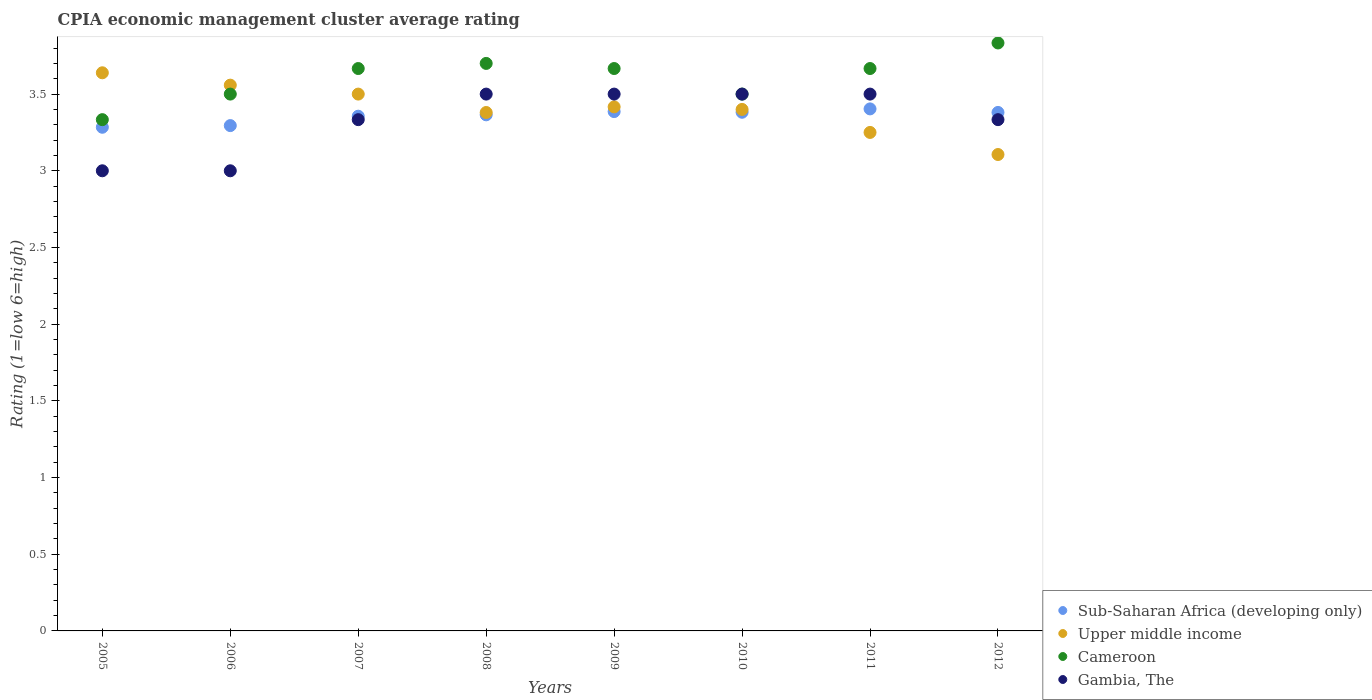What is the CPIA rating in Cameroon in 2008?
Your answer should be compact. 3.7. Across all years, what is the minimum CPIA rating in Upper middle income?
Keep it short and to the point. 3.11. In which year was the CPIA rating in Upper middle income maximum?
Keep it short and to the point. 2005. What is the total CPIA rating in Gambia, The in the graph?
Provide a short and direct response. 26.67. What is the difference between the CPIA rating in Sub-Saharan Africa (developing only) in 2006 and that in 2010?
Provide a short and direct response. -0.09. What is the average CPIA rating in Gambia, The per year?
Provide a short and direct response. 3.33. In the year 2009, what is the difference between the CPIA rating in Sub-Saharan Africa (developing only) and CPIA rating in Cameroon?
Give a very brief answer. -0.28. In how many years, is the CPIA rating in Sub-Saharan Africa (developing only) greater than 1.1?
Provide a short and direct response. 8. What is the difference between the highest and the second highest CPIA rating in Sub-Saharan Africa (developing only)?
Your response must be concise. 0.02. What is the difference between the highest and the lowest CPIA rating in Sub-Saharan Africa (developing only)?
Ensure brevity in your answer.  0.12. In how many years, is the CPIA rating in Sub-Saharan Africa (developing only) greater than the average CPIA rating in Sub-Saharan Africa (developing only) taken over all years?
Offer a terse response. 5. Is the sum of the CPIA rating in Cameroon in 2005 and 2006 greater than the maximum CPIA rating in Sub-Saharan Africa (developing only) across all years?
Offer a very short reply. Yes. Is it the case that in every year, the sum of the CPIA rating in Upper middle income and CPIA rating in Sub-Saharan Africa (developing only)  is greater than the CPIA rating in Gambia, The?
Ensure brevity in your answer.  Yes. Does the CPIA rating in Gambia, The monotonically increase over the years?
Offer a very short reply. No. Is the CPIA rating in Upper middle income strictly greater than the CPIA rating in Sub-Saharan Africa (developing only) over the years?
Offer a terse response. No. What is the difference between two consecutive major ticks on the Y-axis?
Provide a succinct answer. 0.5. Are the values on the major ticks of Y-axis written in scientific E-notation?
Keep it short and to the point. No. Does the graph contain any zero values?
Keep it short and to the point. No. How many legend labels are there?
Provide a short and direct response. 4. How are the legend labels stacked?
Provide a succinct answer. Vertical. What is the title of the graph?
Provide a succinct answer. CPIA economic management cluster average rating. What is the Rating (1=low 6=high) in Sub-Saharan Africa (developing only) in 2005?
Give a very brief answer. 3.28. What is the Rating (1=low 6=high) of Upper middle income in 2005?
Ensure brevity in your answer.  3.64. What is the Rating (1=low 6=high) in Cameroon in 2005?
Make the answer very short. 3.33. What is the Rating (1=low 6=high) of Sub-Saharan Africa (developing only) in 2006?
Provide a short and direct response. 3.29. What is the Rating (1=low 6=high) of Upper middle income in 2006?
Make the answer very short. 3.56. What is the Rating (1=low 6=high) in Sub-Saharan Africa (developing only) in 2007?
Offer a very short reply. 3.36. What is the Rating (1=low 6=high) in Cameroon in 2007?
Offer a terse response. 3.67. What is the Rating (1=low 6=high) in Gambia, The in 2007?
Offer a very short reply. 3.33. What is the Rating (1=low 6=high) in Sub-Saharan Africa (developing only) in 2008?
Ensure brevity in your answer.  3.36. What is the Rating (1=low 6=high) in Upper middle income in 2008?
Offer a terse response. 3.38. What is the Rating (1=low 6=high) in Cameroon in 2008?
Keep it short and to the point. 3.7. What is the Rating (1=low 6=high) in Gambia, The in 2008?
Provide a succinct answer. 3.5. What is the Rating (1=low 6=high) in Sub-Saharan Africa (developing only) in 2009?
Keep it short and to the point. 3.39. What is the Rating (1=low 6=high) of Upper middle income in 2009?
Keep it short and to the point. 3.42. What is the Rating (1=low 6=high) in Cameroon in 2009?
Your answer should be very brief. 3.67. What is the Rating (1=low 6=high) of Sub-Saharan Africa (developing only) in 2010?
Offer a terse response. 3.38. What is the Rating (1=low 6=high) of Upper middle income in 2010?
Offer a very short reply. 3.4. What is the Rating (1=low 6=high) of Gambia, The in 2010?
Offer a very short reply. 3.5. What is the Rating (1=low 6=high) in Sub-Saharan Africa (developing only) in 2011?
Provide a succinct answer. 3.4. What is the Rating (1=low 6=high) in Upper middle income in 2011?
Your response must be concise. 3.25. What is the Rating (1=low 6=high) of Cameroon in 2011?
Ensure brevity in your answer.  3.67. What is the Rating (1=low 6=high) of Gambia, The in 2011?
Give a very brief answer. 3.5. What is the Rating (1=low 6=high) in Sub-Saharan Africa (developing only) in 2012?
Offer a terse response. 3.38. What is the Rating (1=low 6=high) in Upper middle income in 2012?
Offer a very short reply. 3.11. What is the Rating (1=low 6=high) of Cameroon in 2012?
Provide a short and direct response. 3.83. What is the Rating (1=low 6=high) of Gambia, The in 2012?
Give a very brief answer. 3.33. Across all years, what is the maximum Rating (1=low 6=high) in Sub-Saharan Africa (developing only)?
Keep it short and to the point. 3.4. Across all years, what is the maximum Rating (1=low 6=high) of Upper middle income?
Your response must be concise. 3.64. Across all years, what is the maximum Rating (1=low 6=high) in Cameroon?
Offer a terse response. 3.83. Across all years, what is the minimum Rating (1=low 6=high) of Sub-Saharan Africa (developing only)?
Offer a very short reply. 3.28. Across all years, what is the minimum Rating (1=low 6=high) in Upper middle income?
Ensure brevity in your answer.  3.11. Across all years, what is the minimum Rating (1=low 6=high) in Cameroon?
Provide a short and direct response. 3.33. Across all years, what is the minimum Rating (1=low 6=high) of Gambia, The?
Offer a very short reply. 3. What is the total Rating (1=low 6=high) of Sub-Saharan Africa (developing only) in the graph?
Your answer should be very brief. 26.85. What is the total Rating (1=low 6=high) in Upper middle income in the graph?
Your response must be concise. 27.25. What is the total Rating (1=low 6=high) in Cameroon in the graph?
Your response must be concise. 28.87. What is the total Rating (1=low 6=high) in Gambia, The in the graph?
Offer a very short reply. 26.67. What is the difference between the Rating (1=low 6=high) in Sub-Saharan Africa (developing only) in 2005 and that in 2006?
Ensure brevity in your answer.  -0.01. What is the difference between the Rating (1=low 6=high) in Upper middle income in 2005 and that in 2006?
Ensure brevity in your answer.  0.08. What is the difference between the Rating (1=low 6=high) in Cameroon in 2005 and that in 2006?
Provide a short and direct response. -0.17. What is the difference between the Rating (1=low 6=high) in Gambia, The in 2005 and that in 2006?
Make the answer very short. 0. What is the difference between the Rating (1=low 6=high) of Sub-Saharan Africa (developing only) in 2005 and that in 2007?
Offer a terse response. -0.07. What is the difference between the Rating (1=low 6=high) of Upper middle income in 2005 and that in 2007?
Give a very brief answer. 0.14. What is the difference between the Rating (1=low 6=high) in Gambia, The in 2005 and that in 2007?
Ensure brevity in your answer.  -0.33. What is the difference between the Rating (1=low 6=high) of Sub-Saharan Africa (developing only) in 2005 and that in 2008?
Your answer should be very brief. -0.08. What is the difference between the Rating (1=low 6=high) of Upper middle income in 2005 and that in 2008?
Make the answer very short. 0.26. What is the difference between the Rating (1=low 6=high) of Cameroon in 2005 and that in 2008?
Your answer should be very brief. -0.37. What is the difference between the Rating (1=low 6=high) in Gambia, The in 2005 and that in 2008?
Offer a terse response. -0.5. What is the difference between the Rating (1=low 6=high) in Sub-Saharan Africa (developing only) in 2005 and that in 2009?
Keep it short and to the point. -0.1. What is the difference between the Rating (1=low 6=high) of Upper middle income in 2005 and that in 2009?
Keep it short and to the point. 0.22. What is the difference between the Rating (1=low 6=high) of Sub-Saharan Africa (developing only) in 2005 and that in 2010?
Your response must be concise. -0.1. What is the difference between the Rating (1=low 6=high) of Upper middle income in 2005 and that in 2010?
Provide a short and direct response. 0.24. What is the difference between the Rating (1=low 6=high) in Sub-Saharan Africa (developing only) in 2005 and that in 2011?
Offer a terse response. -0.12. What is the difference between the Rating (1=low 6=high) in Upper middle income in 2005 and that in 2011?
Your answer should be compact. 0.39. What is the difference between the Rating (1=low 6=high) in Cameroon in 2005 and that in 2011?
Provide a succinct answer. -0.33. What is the difference between the Rating (1=low 6=high) of Gambia, The in 2005 and that in 2011?
Make the answer very short. -0.5. What is the difference between the Rating (1=low 6=high) of Sub-Saharan Africa (developing only) in 2005 and that in 2012?
Provide a short and direct response. -0.1. What is the difference between the Rating (1=low 6=high) in Upper middle income in 2005 and that in 2012?
Provide a short and direct response. 0.53. What is the difference between the Rating (1=low 6=high) in Cameroon in 2005 and that in 2012?
Your response must be concise. -0.5. What is the difference between the Rating (1=low 6=high) in Sub-Saharan Africa (developing only) in 2006 and that in 2007?
Offer a very short reply. -0.06. What is the difference between the Rating (1=low 6=high) in Upper middle income in 2006 and that in 2007?
Offer a terse response. 0.06. What is the difference between the Rating (1=low 6=high) of Cameroon in 2006 and that in 2007?
Provide a short and direct response. -0.17. What is the difference between the Rating (1=low 6=high) in Gambia, The in 2006 and that in 2007?
Your answer should be very brief. -0.33. What is the difference between the Rating (1=low 6=high) in Sub-Saharan Africa (developing only) in 2006 and that in 2008?
Make the answer very short. -0.07. What is the difference between the Rating (1=low 6=high) in Upper middle income in 2006 and that in 2008?
Make the answer very short. 0.18. What is the difference between the Rating (1=low 6=high) in Gambia, The in 2006 and that in 2008?
Offer a very short reply. -0.5. What is the difference between the Rating (1=low 6=high) in Sub-Saharan Africa (developing only) in 2006 and that in 2009?
Provide a succinct answer. -0.09. What is the difference between the Rating (1=low 6=high) in Upper middle income in 2006 and that in 2009?
Ensure brevity in your answer.  0.14. What is the difference between the Rating (1=low 6=high) of Gambia, The in 2006 and that in 2009?
Your answer should be compact. -0.5. What is the difference between the Rating (1=low 6=high) in Sub-Saharan Africa (developing only) in 2006 and that in 2010?
Make the answer very short. -0.09. What is the difference between the Rating (1=low 6=high) of Upper middle income in 2006 and that in 2010?
Keep it short and to the point. 0.16. What is the difference between the Rating (1=low 6=high) of Cameroon in 2006 and that in 2010?
Your response must be concise. 0. What is the difference between the Rating (1=low 6=high) in Gambia, The in 2006 and that in 2010?
Keep it short and to the point. -0.5. What is the difference between the Rating (1=low 6=high) of Sub-Saharan Africa (developing only) in 2006 and that in 2011?
Offer a terse response. -0.11. What is the difference between the Rating (1=low 6=high) in Upper middle income in 2006 and that in 2011?
Make the answer very short. 0.31. What is the difference between the Rating (1=low 6=high) in Gambia, The in 2006 and that in 2011?
Give a very brief answer. -0.5. What is the difference between the Rating (1=low 6=high) of Sub-Saharan Africa (developing only) in 2006 and that in 2012?
Ensure brevity in your answer.  -0.09. What is the difference between the Rating (1=low 6=high) of Upper middle income in 2006 and that in 2012?
Keep it short and to the point. 0.45. What is the difference between the Rating (1=low 6=high) in Gambia, The in 2006 and that in 2012?
Make the answer very short. -0.33. What is the difference between the Rating (1=low 6=high) of Sub-Saharan Africa (developing only) in 2007 and that in 2008?
Make the answer very short. -0.01. What is the difference between the Rating (1=low 6=high) in Upper middle income in 2007 and that in 2008?
Offer a terse response. 0.12. What is the difference between the Rating (1=low 6=high) of Cameroon in 2007 and that in 2008?
Ensure brevity in your answer.  -0.03. What is the difference between the Rating (1=low 6=high) of Sub-Saharan Africa (developing only) in 2007 and that in 2009?
Your answer should be compact. -0.03. What is the difference between the Rating (1=low 6=high) of Upper middle income in 2007 and that in 2009?
Offer a very short reply. 0.08. What is the difference between the Rating (1=low 6=high) of Cameroon in 2007 and that in 2009?
Keep it short and to the point. 0. What is the difference between the Rating (1=low 6=high) of Sub-Saharan Africa (developing only) in 2007 and that in 2010?
Your answer should be very brief. -0.03. What is the difference between the Rating (1=low 6=high) in Sub-Saharan Africa (developing only) in 2007 and that in 2011?
Ensure brevity in your answer.  -0.05. What is the difference between the Rating (1=low 6=high) in Upper middle income in 2007 and that in 2011?
Offer a terse response. 0.25. What is the difference between the Rating (1=low 6=high) of Cameroon in 2007 and that in 2011?
Offer a terse response. 0. What is the difference between the Rating (1=low 6=high) of Gambia, The in 2007 and that in 2011?
Make the answer very short. -0.17. What is the difference between the Rating (1=low 6=high) of Sub-Saharan Africa (developing only) in 2007 and that in 2012?
Keep it short and to the point. -0.02. What is the difference between the Rating (1=low 6=high) in Upper middle income in 2007 and that in 2012?
Your response must be concise. 0.39. What is the difference between the Rating (1=low 6=high) in Cameroon in 2007 and that in 2012?
Offer a very short reply. -0.17. What is the difference between the Rating (1=low 6=high) in Sub-Saharan Africa (developing only) in 2008 and that in 2009?
Offer a very short reply. -0.02. What is the difference between the Rating (1=low 6=high) of Upper middle income in 2008 and that in 2009?
Provide a short and direct response. -0.04. What is the difference between the Rating (1=low 6=high) in Cameroon in 2008 and that in 2009?
Your answer should be very brief. 0.03. What is the difference between the Rating (1=low 6=high) of Gambia, The in 2008 and that in 2009?
Provide a short and direct response. 0. What is the difference between the Rating (1=low 6=high) in Sub-Saharan Africa (developing only) in 2008 and that in 2010?
Provide a short and direct response. -0.02. What is the difference between the Rating (1=low 6=high) of Upper middle income in 2008 and that in 2010?
Keep it short and to the point. -0.02. What is the difference between the Rating (1=low 6=high) of Gambia, The in 2008 and that in 2010?
Your answer should be compact. 0. What is the difference between the Rating (1=low 6=high) of Sub-Saharan Africa (developing only) in 2008 and that in 2011?
Offer a very short reply. -0.04. What is the difference between the Rating (1=low 6=high) of Upper middle income in 2008 and that in 2011?
Give a very brief answer. 0.13. What is the difference between the Rating (1=low 6=high) in Gambia, The in 2008 and that in 2011?
Ensure brevity in your answer.  0. What is the difference between the Rating (1=low 6=high) of Sub-Saharan Africa (developing only) in 2008 and that in 2012?
Keep it short and to the point. -0.02. What is the difference between the Rating (1=low 6=high) in Upper middle income in 2008 and that in 2012?
Give a very brief answer. 0.27. What is the difference between the Rating (1=low 6=high) in Cameroon in 2008 and that in 2012?
Provide a succinct answer. -0.13. What is the difference between the Rating (1=low 6=high) of Sub-Saharan Africa (developing only) in 2009 and that in 2010?
Give a very brief answer. 0. What is the difference between the Rating (1=low 6=high) of Upper middle income in 2009 and that in 2010?
Your answer should be very brief. 0.02. What is the difference between the Rating (1=low 6=high) in Cameroon in 2009 and that in 2010?
Provide a succinct answer. 0.17. What is the difference between the Rating (1=low 6=high) of Gambia, The in 2009 and that in 2010?
Offer a terse response. 0. What is the difference between the Rating (1=low 6=high) of Sub-Saharan Africa (developing only) in 2009 and that in 2011?
Offer a very short reply. -0.02. What is the difference between the Rating (1=low 6=high) of Upper middle income in 2009 and that in 2011?
Make the answer very short. 0.17. What is the difference between the Rating (1=low 6=high) of Sub-Saharan Africa (developing only) in 2009 and that in 2012?
Your answer should be very brief. 0.01. What is the difference between the Rating (1=low 6=high) of Upper middle income in 2009 and that in 2012?
Your answer should be compact. 0.31. What is the difference between the Rating (1=low 6=high) in Cameroon in 2009 and that in 2012?
Offer a terse response. -0.17. What is the difference between the Rating (1=low 6=high) in Sub-Saharan Africa (developing only) in 2010 and that in 2011?
Your answer should be very brief. -0.02. What is the difference between the Rating (1=low 6=high) in Sub-Saharan Africa (developing only) in 2010 and that in 2012?
Your response must be concise. 0. What is the difference between the Rating (1=low 6=high) in Upper middle income in 2010 and that in 2012?
Offer a terse response. 0.29. What is the difference between the Rating (1=low 6=high) in Gambia, The in 2010 and that in 2012?
Provide a succinct answer. 0.17. What is the difference between the Rating (1=low 6=high) of Sub-Saharan Africa (developing only) in 2011 and that in 2012?
Offer a very short reply. 0.02. What is the difference between the Rating (1=low 6=high) in Upper middle income in 2011 and that in 2012?
Offer a very short reply. 0.14. What is the difference between the Rating (1=low 6=high) in Cameroon in 2011 and that in 2012?
Offer a very short reply. -0.17. What is the difference between the Rating (1=low 6=high) of Gambia, The in 2011 and that in 2012?
Your answer should be compact. 0.17. What is the difference between the Rating (1=low 6=high) in Sub-Saharan Africa (developing only) in 2005 and the Rating (1=low 6=high) in Upper middle income in 2006?
Provide a succinct answer. -0.27. What is the difference between the Rating (1=low 6=high) in Sub-Saharan Africa (developing only) in 2005 and the Rating (1=low 6=high) in Cameroon in 2006?
Keep it short and to the point. -0.22. What is the difference between the Rating (1=low 6=high) in Sub-Saharan Africa (developing only) in 2005 and the Rating (1=low 6=high) in Gambia, The in 2006?
Offer a very short reply. 0.28. What is the difference between the Rating (1=low 6=high) of Upper middle income in 2005 and the Rating (1=low 6=high) of Cameroon in 2006?
Your answer should be very brief. 0.14. What is the difference between the Rating (1=low 6=high) of Upper middle income in 2005 and the Rating (1=low 6=high) of Gambia, The in 2006?
Make the answer very short. 0.64. What is the difference between the Rating (1=low 6=high) of Sub-Saharan Africa (developing only) in 2005 and the Rating (1=low 6=high) of Upper middle income in 2007?
Ensure brevity in your answer.  -0.22. What is the difference between the Rating (1=low 6=high) of Sub-Saharan Africa (developing only) in 2005 and the Rating (1=low 6=high) of Cameroon in 2007?
Ensure brevity in your answer.  -0.38. What is the difference between the Rating (1=low 6=high) of Sub-Saharan Africa (developing only) in 2005 and the Rating (1=low 6=high) of Gambia, The in 2007?
Offer a very short reply. -0.05. What is the difference between the Rating (1=low 6=high) of Upper middle income in 2005 and the Rating (1=low 6=high) of Cameroon in 2007?
Your answer should be very brief. -0.03. What is the difference between the Rating (1=low 6=high) of Upper middle income in 2005 and the Rating (1=low 6=high) of Gambia, The in 2007?
Offer a terse response. 0.31. What is the difference between the Rating (1=low 6=high) in Sub-Saharan Africa (developing only) in 2005 and the Rating (1=low 6=high) in Upper middle income in 2008?
Your answer should be compact. -0.1. What is the difference between the Rating (1=low 6=high) in Sub-Saharan Africa (developing only) in 2005 and the Rating (1=low 6=high) in Cameroon in 2008?
Keep it short and to the point. -0.42. What is the difference between the Rating (1=low 6=high) in Sub-Saharan Africa (developing only) in 2005 and the Rating (1=low 6=high) in Gambia, The in 2008?
Your answer should be very brief. -0.22. What is the difference between the Rating (1=low 6=high) in Upper middle income in 2005 and the Rating (1=low 6=high) in Cameroon in 2008?
Provide a succinct answer. -0.06. What is the difference between the Rating (1=low 6=high) of Upper middle income in 2005 and the Rating (1=low 6=high) of Gambia, The in 2008?
Your answer should be compact. 0.14. What is the difference between the Rating (1=low 6=high) in Sub-Saharan Africa (developing only) in 2005 and the Rating (1=low 6=high) in Upper middle income in 2009?
Offer a very short reply. -0.13. What is the difference between the Rating (1=low 6=high) in Sub-Saharan Africa (developing only) in 2005 and the Rating (1=low 6=high) in Cameroon in 2009?
Provide a succinct answer. -0.38. What is the difference between the Rating (1=low 6=high) of Sub-Saharan Africa (developing only) in 2005 and the Rating (1=low 6=high) of Gambia, The in 2009?
Offer a terse response. -0.22. What is the difference between the Rating (1=low 6=high) in Upper middle income in 2005 and the Rating (1=low 6=high) in Cameroon in 2009?
Your response must be concise. -0.03. What is the difference between the Rating (1=low 6=high) of Upper middle income in 2005 and the Rating (1=low 6=high) of Gambia, The in 2009?
Ensure brevity in your answer.  0.14. What is the difference between the Rating (1=low 6=high) of Sub-Saharan Africa (developing only) in 2005 and the Rating (1=low 6=high) of Upper middle income in 2010?
Provide a succinct answer. -0.12. What is the difference between the Rating (1=low 6=high) of Sub-Saharan Africa (developing only) in 2005 and the Rating (1=low 6=high) of Cameroon in 2010?
Offer a terse response. -0.22. What is the difference between the Rating (1=low 6=high) of Sub-Saharan Africa (developing only) in 2005 and the Rating (1=low 6=high) of Gambia, The in 2010?
Provide a succinct answer. -0.22. What is the difference between the Rating (1=low 6=high) in Upper middle income in 2005 and the Rating (1=low 6=high) in Cameroon in 2010?
Your response must be concise. 0.14. What is the difference between the Rating (1=low 6=high) of Upper middle income in 2005 and the Rating (1=low 6=high) of Gambia, The in 2010?
Ensure brevity in your answer.  0.14. What is the difference between the Rating (1=low 6=high) in Cameroon in 2005 and the Rating (1=low 6=high) in Gambia, The in 2010?
Offer a terse response. -0.17. What is the difference between the Rating (1=low 6=high) of Sub-Saharan Africa (developing only) in 2005 and the Rating (1=low 6=high) of Upper middle income in 2011?
Ensure brevity in your answer.  0.03. What is the difference between the Rating (1=low 6=high) in Sub-Saharan Africa (developing only) in 2005 and the Rating (1=low 6=high) in Cameroon in 2011?
Provide a short and direct response. -0.38. What is the difference between the Rating (1=low 6=high) of Sub-Saharan Africa (developing only) in 2005 and the Rating (1=low 6=high) of Gambia, The in 2011?
Keep it short and to the point. -0.22. What is the difference between the Rating (1=low 6=high) in Upper middle income in 2005 and the Rating (1=low 6=high) in Cameroon in 2011?
Offer a terse response. -0.03. What is the difference between the Rating (1=low 6=high) in Upper middle income in 2005 and the Rating (1=low 6=high) in Gambia, The in 2011?
Give a very brief answer. 0.14. What is the difference between the Rating (1=low 6=high) in Sub-Saharan Africa (developing only) in 2005 and the Rating (1=low 6=high) in Upper middle income in 2012?
Provide a succinct answer. 0.18. What is the difference between the Rating (1=low 6=high) of Sub-Saharan Africa (developing only) in 2005 and the Rating (1=low 6=high) of Cameroon in 2012?
Your answer should be very brief. -0.55. What is the difference between the Rating (1=low 6=high) in Sub-Saharan Africa (developing only) in 2005 and the Rating (1=low 6=high) in Gambia, The in 2012?
Give a very brief answer. -0.05. What is the difference between the Rating (1=low 6=high) of Upper middle income in 2005 and the Rating (1=low 6=high) of Cameroon in 2012?
Make the answer very short. -0.19. What is the difference between the Rating (1=low 6=high) of Upper middle income in 2005 and the Rating (1=low 6=high) of Gambia, The in 2012?
Provide a succinct answer. 0.31. What is the difference between the Rating (1=low 6=high) in Cameroon in 2005 and the Rating (1=low 6=high) in Gambia, The in 2012?
Offer a very short reply. 0. What is the difference between the Rating (1=low 6=high) of Sub-Saharan Africa (developing only) in 2006 and the Rating (1=low 6=high) of Upper middle income in 2007?
Offer a very short reply. -0.21. What is the difference between the Rating (1=low 6=high) in Sub-Saharan Africa (developing only) in 2006 and the Rating (1=low 6=high) in Cameroon in 2007?
Keep it short and to the point. -0.37. What is the difference between the Rating (1=low 6=high) of Sub-Saharan Africa (developing only) in 2006 and the Rating (1=low 6=high) of Gambia, The in 2007?
Make the answer very short. -0.04. What is the difference between the Rating (1=low 6=high) of Upper middle income in 2006 and the Rating (1=low 6=high) of Cameroon in 2007?
Your answer should be very brief. -0.11. What is the difference between the Rating (1=low 6=high) in Upper middle income in 2006 and the Rating (1=low 6=high) in Gambia, The in 2007?
Offer a very short reply. 0.23. What is the difference between the Rating (1=low 6=high) of Cameroon in 2006 and the Rating (1=low 6=high) of Gambia, The in 2007?
Ensure brevity in your answer.  0.17. What is the difference between the Rating (1=low 6=high) of Sub-Saharan Africa (developing only) in 2006 and the Rating (1=low 6=high) of Upper middle income in 2008?
Your answer should be compact. -0.09. What is the difference between the Rating (1=low 6=high) in Sub-Saharan Africa (developing only) in 2006 and the Rating (1=low 6=high) in Cameroon in 2008?
Offer a very short reply. -0.41. What is the difference between the Rating (1=low 6=high) in Sub-Saharan Africa (developing only) in 2006 and the Rating (1=low 6=high) in Gambia, The in 2008?
Keep it short and to the point. -0.21. What is the difference between the Rating (1=low 6=high) of Upper middle income in 2006 and the Rating (1=low 6=high) of Cameroon in 2008?
Give a very brief answer. -0.14. What is the difference between the Rating (1=low 6=high) in Upper middle income in 2006 and the Rating (1=low 6=high) in Gambia, The in 2008?
Make the answer very short. 0.06. What is the difference between the Rating (1=low 6=high) in Cameroon in 2006 and the Rating (1=low 6=high) in Gambia, The in 2008?
Your response must be concise. 0. What is the difference between the Rating (1=low 6=high) in Sub-Saharan Africa (developing only) in 2006 and the Rating (1=low 6=high) in Upper middle income in 2009?
Give a very brief answer. -0.12. What is the difference between the Rating (1=low 6=high) of Sub-Saharan Africa (developing only) in 2006 and the Rating (1=low 6=high) of Cameroon in 2009?
Provide a short and direct response. -0.37. What is the difference between the Rating (1=low 6=high) of Sub-Saharan Africa (developing only) in 2006 and the Rating (1=low 6=high) of Gambia, The in 2009?
Your response must be concise. -0.21. What is the difference between the Rating (1=low 6=high) of Upper middle income in 2006 and the Rating (1=low 6=high) of Cameroon in 2009?
Your response must be concise. -0.11. What is the difference between the Rating (1=low 6=high) in Upper middle income in 2006 and the Rating (1=low 6=high) in Gambia, The in 2009?
Provide a short and direct response. 0.06. What is the difference between the Rating (1=low 6=high) in Sub-Saharan Africa (developing only) in 2006 and the Rating (1=low 6=high) in Upper middle income in 2010?
Offer a very short reply. -0.11. What is the difference between the Rating (1=low 6=high) of Sub-Saharan Africa (developing only) in 2006 and the Rating (1=low 6=high) of Cameroon in 2010?
Offer a very short reply. -0.21. What is the difference between the Rating (1=low 6=high) in Sub-Saharan Africa (developing only) in 2006 and the Rating (1=low 6=high) in Gambia, The in 2010?
Give a very brief answer. -0.21. What is the difference between the Rating (1=low 6=high) in Upper middle income in 2006 and the Rating (1=low 6=high) in Cameroon in 2010?
Your response must be concise. 0.06. What is the difference between the Rating (1=low 6=high) of Upper middle income in 2006 and the Rating (1=low 6=high) of Gambia, The in 2010?
Offer a very short reply. 0.06. What is the difference between the Rating (1=low 6=high) of Sub-Saharan Africa (developing only) in 2006 and the Rating (1=low 6=high) of Upper middle income in 2011?
Keep it short and to the point. 0.04. What is the difference between the Rating (1=low 6=high) of Sub-Saharan Africa (developing only) in 2006 and the Rating (1=low 6=high) of Cameroon in 2011?
Ensure brevity in your answer.  -0.37. What is the difference between the Rating (1=low 6=high) in Sub-Saharan Africa (developing only) in 2006 and the Rating (1=low 6=high) in Gambia, The in 2011?
Keep it short and to the point. -0.21. What is the difference between the Rating (1=low 6=high) in Upper middle income in 2006 and the Rating (1=low 6=high) in Cameroon in 2011?
Give a very brief answer. -0.11. What is the difference between the Rating (1=low 6=high) in Upper middle income in 2006 and the Rating (1=low 6=high) in Gambia, The in 2011?
Your answer should be very brief. 0.06. What is the difference between the Rating (1=low 6=high) of Sub-Saharan Africa (developing only) in 2006 and the Rating (1=low 6=high) of Upper middle income in 2012?
Make the answer very short. 0.19. What is the difference between the Rating (1=low 6=high) of Sub-Saharan Africa (developing only) in 2006 and the Rating (1=low 6=high) of Cameroon in 2012?
Your answer should be compact. -0.54. What is the difference between the Rating (1=low 6=high) in Sub-Saharan Africa (developing only) in 2006 and the Rating (1=low 6=high) in Gambia, The in 2012?
Provide a short and direct response. -0.04. What is the difference between the Rating (1=low 6=high) in Upper middle income in 2006 and the Rating (1=low 6=high) in Cameroon in 2012?
Your answer should be compact. -0.28. What is the difference between the Rating (1=low 6=high) in Upper middle income in 2006 and the Rating (1=low 6=high) in Gambia, The in 2012?
Give a very brief answer. 0.23. What is the difference between the Rating (1=low 6=high) in Sub-Saharan Africa (developing only) in 2007 and the Rating (1=low 6=high) in Upper middle income in 2008?
Provide a short and direct response. -0.02. What is the difference between the Rating (1=low 6=high) of Sub-Saharan Africa (developing only) in 2007 and the Rating (1=low 6=high) of Cameroon in 2008?
Provide a succinct answer. -0.34. What is the difference between the Rating (1=low 6=high) of Sub-Saharan Africa (developing only) in 2007 and the Rating (1=low 6=high) of Gambia, The in 2008?
Your answer should be compact. -0.14. What is the difference between the Rating (1=low 6=high) of Upper middle income in 2007 and the Rating (1=low 6=high) of Gambia, The in 2008?
Provide a succinct answer. 0. What is the difference between the Rating (1=low 6=high) of Cameroon in 2007 and the Rating (1=low 6=high) of Gambia, The in 2008?
Ensure brevity in your answer.  0.17. What is the difference between the Rating (1=low 6=high) of Sub-Saharan Africa (developing only) in 2007 and the Rating (1=low 6=high) of Upper middle income in 2009?
Give a very brief answer. -0.06. What is the difference between the Rating (1=low 6=high) in Sub-Saharan Africa (developing only) in 2007 and the Rating (1=low 6=high) in Cameroon in 2009?
Ensure brevity in your answer.  -0.31. What is the difference between the Rating (1=low 6=high) in Sub-Saharan Africa (developing only) in 2007 and the Rating (1=low 6=high) in Gambia, The in 2009?
Offer a terse response. -0.14. What is the difference between the Rating (1=low 6=high) in Upper middle income in 2007 and the Rating (1=low 6=high) in Cameroon in 2009?
Your answer should be very brief. -0.17. What is the difference between the Rating (1=low 6=high) of Upper middle income in 2007 and the Rating (1=low 6=high) of Gambia, The in 2009?
Ensure brevity in your answer.  0. What is the difference between the Rating (1=low 6=high) in Cameroon in 2007 and the Rating (1=low 6=high) in Gambia, The in 2009?
Your response must be concise. 0.17. What is the difference between the Rating (1=low 6=high) of Sub-Saharan Africa (developing only) in 2007 and the Rating (1=low 6=high) of Upper middle income in 2010?
Keep it short and to the point. -0.04. What is the difference between the Rating (1=low 6=high) of Sub-Saharan Africa (developing only) in 2007 and the Rating (1=low 6=high) of Cameroon in 2010?
Ensure brevity in your answer.  -0.14. What is the difference between the Rating (1=low 6=high) of Sub-Saharan Africa (developing only) in 2007 and the Rating (1=low 6=high) of Gambia, The in 2010?
Provide a short and direct response. -0.14. What is the difference between the Rating (1=low 6=high) of Sub-Saharan Africa (developing only) in 2007 and the Rating (1=low 6=high) of Upper middle income in 2011?
Your answer should be compact. 0.11. What is the difference between the Rating (1=low 6=high) of Sub-Saharan Africa (developing only) in 2007 and the Rating (1=low 6=high) of Cameroon in 2011?
Offer a very short reply. -0.31. What is the difference between the Rating (1=low 6=high) in Sub-Saharan Africa (developing only) in 2007 and the Rating (1=low 6=high) in Gambia, The in 2011?
Your response must be concise. -0.14. What is the difference between the Rating (1=low 6=high) of Upper middle income in 2007 and the Rating (1=low 6=high) of Gambia, The in 2011?
Provide a short and direct response. 0. What is the difference between the Rating (1=low 6=high) in Sub-Saharan Africa (developing only) in 2007 and the Rating (1=low 6=high) in Upper middle income in 2012?
Ensure brevity in your answer.  0.25. What is the difference between the Rating (1=low 6=high) in Sub-Saharan Africa (developing only) in 2007 and the Rating (1=low 6=high) in Cameroon in 2012?
Offer a very short reply. -0.48. What is the difference between the Rating (1=low 6=high) in Sub-Saharan Africa (developing only) in 2007 and the Rating (1=low 6=high) in Gambia, The in 2012?
Your answer should be compact. 0.02. What is the difference between the Rating (1=low 6=high) in Upper middle income in 2007 and the Rating (1=low 6=high) in Cameroon in 2012?
Ensure brevity in your answer.  -0.33. What is the difference between the Rating (1=low 6=high) of Upper middle income in 2007 and the Rating (1=low 6=high) of Gambia, The in 2012?
Ensure brevity in your answer.  0.17. What is the difference between the Rating (1=low 6=high) in Cameroon in 2007 and the Rating (1=low 6=high) in Gambia, The in 2012?
Give a very brief answer. 0.33. What is the difference between the Rating (1=low 6=high) in Sub-Saharan Africa (developing only) in 2008 and the Rating (1=low 6=high) in Upper middle income in 2009?
Provide a succinct answer. -0.05. What is the difference between the Rating (1=low 6=high) in Sub-Saharan Africa (developing only) in 2008 and the Rating (1=low 6=high) in Cameroon in 2009?
Give a very brief answer. -0.3. What is the difference between the Rating (1=low 6=high) in Sub-Saharan Africa (developing only) in 2008 and the Rating (1=low 6=high) in Gambia, The in 2009?
Provide a succinct answer. -0.14. What is the difference between the Rating (1=low 6=high) in Upper middle income in 2008 and the Rating (1=low 6=high) in Cameroon in 2009?
Ensure brevity in your answer.  -0.29. What is the difference between the Rating (1=low 6=high) in Upper middle income in 2008 and the Rating (1=low 6=high) in Gambia, The in 2009?
Make the answer very short. -0.12. What is the difference between the Rating (1=low 6=high) in Sub-Saharan Africa (developing only) in 2008 and the Rating (1=low 6=high) in Upper middle income in 2010?
Offer a very short reply. -0.04. What is the difference between the Rating (1=low 6=high) in Sub-Saharan Africa (developing only) in 2008 and the Rating (1=low 6=high) in Cameroon in 2010?
Keep it short and to the point. -0.14. What is the difference between the Rating (1=low 6=high) in Sub-Saharan Africa (developing only) in 2008 and the Rating (1=low 6=high) in Gambia, The in 2010?
Provide a short and direct response. -0.14. What is the difference between the Rating (1=low 6=high) of Upper middle income in 2008 and the Rating (1=low 6=high) of Cameroon in 2010?
Offer a terse response. -0.12. What is the difference between the Rating (1=low 6=high) in Upper middle income in 2008 and the Rating (1=low 6=high) in Gambia, The in 2010?
Keep it short and to the point. -0.12. What is the difference between the Rating (1=low 6=high) of Cameroon in 2008 and the Rating (1=low 6=high) of Gambia, The in 2010?
Your response must be concise. 0.2. What is the difference between the Rating (1=low 6=high) of Sub-Saharan Africa (developing only) in 2008 and the Rating (1=low 6=high) of Upper middle income in 2011?
Keep it short and to the point. 0.11. What is the difference between the Rating (1=low 6=high) in Sub-Saharan Africa (developing only) in 2008 and the Rating (1=low 6=high) in Cameroon in 2011?
Make the answer very short. -0.3. What is the difference between the Rating (1=low 6=high) in Sub-Saharan Africa (developing only) in 2008 and the Rating (1=low 6=high) in Gambia, The in 2011?
Offer a very short reply. -0.14. What is the difference between the Rating (1=low 6=high) of Upper middle income in 2008 and the Rating (1=low 6=high) of Cameroon in 2011?
Ensure brevity in your answer.  -0.29. What is the difference between the Rating (1=low 6=high) in Upper middle income in 2008 and the Rating (1=low 6=high) in Gambia, The in 2011?
Offer a terse response. -0.12. What is the difference between the Rating (1=low 6=high) in Cameroon in 2008 and the Rating (1=low 6=high) in Gambia, The in 2011?
Ensure brevity in your answer.  0.2. What is the difference between the Rating (1=low 6=high) of Sub-Saharan Africa (developing only) in 2008 and the Rating (1=low 6=high) of Upper middle income in 2012?
Offer a very short reply. 0.26. What is the difference between the Rating (1=low 6=high) of Sub-Saharan Africa (developing only) in 2008 and the Rating (1=low 6=high) of Cameroon in 2012?
Give a very brief answer. -0.47. What is the difference between the Rating (1=low 6=high) in Sub-Saharan Africa (developing only) in 2008 and the Rating (1=low 6=high) in Gambia, The in 2012?
Your answer should be compact. 0.03. What is the difference between the Rating (1=low 6=high) in Upper middle income in 2008 and the Rating (1=low 6=high) in Cameroon in 2012?
Make the answer very short. -0.45. What is the difference between the Rating (1=low 6=high) in Upper middle income in 2008 and the Rating (1=low 6=high) in Gambia, The in 2012?
Offer a terse response. 0.05. What is the difference between the Rating (1=low 6=high) of Cameroon in 2008 and the Rating (1=low 6=high) of Gambia, The in 2012?
Ensure brevity in your answer.  0.37. What is the difference between the Rating (1=low 6=high) of Sub-Saharan Africa (developing only) in 2009 and the Rating (1=low 6=high) of Upper middle income in 2010?
Your answer should be very brief. -0.01. What is the difference between the Rating (1=low 6=high) in Sub-Saharan Africa (developing only) in 2009 and the Rating (1=low 6=high) in Cameroon in 2010?
Make the answer very short. -0.11. What is the difference between the Rating (1=low 6=high) in Sub-Saharan Africa (developing only) in 2009 and the Rating (1=low 6=high) in Gambia, The in 2010?
Offer a very short reply. -0.11. What is the difference between the Rating (1=low 6=high) of Upper middle income in 2009 and the Rating (1=low 6=high) of Cameroon in 2010?
Offer a terse response. -0.08. What is the difference between the Rating (1=low 6=high) of Upper middle income in 2009 and the Rating (1=low 6=high) of Gambia, The in 2010?
Provide a succinct answer. -0.08. What is the difference between the Rating (1=low 6=high) in Cameroon in 2009 and the Rating (1=low 6=high) in Gambia, The in 2010?
Your answer should be very brief. 0.17. What is the difference between the Rating (1=low 6=high) in Sub-Saharan Africa (developing only) in 2009 and the Rating (1=low 6=high) in Upper middle income in 2011?
Provide a succinct answer. 0.14. What is the difference between the Rating (1=low 6=high) of Sub-Saharan Africa (developing only) in 2009 and the Rating (1=low 6=high) of Cameroon in 2011?
Provide a succinct answer. -0.28. What is the difference between the Rating (1=low 6=high) in Sub-Saharan Africa (developing only) in 2009 and the Rating (1=low 6=high) in Gambia, The in 2011?
Give a very brief answer. -0.11. What is the difference between the Rating (1=low 6=high) in Upper middle income in 2009 and the Rating (1=low 6=high) in Cameroon in 2011?
Your answer should be very brief. -0.25. What is the difference between the Rating (1=low 6=high) of Upper middle income in 2009 and the Rating (1=low 6=high) of Gambia, The in 2011?
Provide a succinct answer. -0.08. What is the difference between the Rating (1=low 6=high) in Cameroon in 2009 and the Rating (1=low 6=high) in Gambia, The in 2011?
Offer a very short reply. 0.17. What is the difference between the Rating (1=low 6=high) of Sub-Saharan Africa (developing only) in 2009 and the Rating (1=low 6=high) of Upper middle income in 2012?
Offer a terse response. 0.28. What is the difference between the Rating (1=low 6=high) of Sub-Saharan Africa (developing only) in 2009 and the Rating (1=low 6=high) of Cameroon in 2012?
Your answer should be compact. -0.45. What is the difference between the Rating (1=low 6=high) in Sub-Saharan Africa (developing only) in 2009 and the Rating (1=low 6=high) in Gambia, The in 2012?
Keep it short and to the point. 0.05. What is the difference between the Rating (1=low 6=high) in Upper middle income in 2009 and the Rating (1=low 6=high) in Cameroon in 2012?
Provide a succinct answer. -0.42. What is the difference between the Rating (1=low 6=high) of Upper middle income in 2009 and the Rating (1=low 6=high) of Gambia, The in 2012?
Provide a succinct answer. 0.08. What is the difference between the Rating (1=low 6=high) in Sub-Saharan Africa (developing only) in 2010 and the Rating (1=low 6=high) in Upper middle income in 2011?
Your answer should be very brief. 0.13. What is the difference between the Rating (1=low 6=high) in Sub-Saharan Africa (developing only) in 2010 and the Rating (1=low 6=high) in Cameroon in 2011?
Ensure brevity in your answer.  -0.29. What is the difference between the Rating (1=low 6=high) of Sub-Saharan Africa (developing only) in 2010 and the Rating (1=low 6=high) of Gambia, The in 2011?
Offer a very short reply. -0.12. What is the difference between the Rating (1=low 6=high) in Upper middle income in 2010 and the Rating (1=low 6=high) in Cameroon in 2011?
Offer a terse response. -0.27. What is the difference between the Rating (1=low 6=high) in Upper middle income in 2010 and the Rating (1=low 6=high) in Gambia, The in 2011?
Your answer should be compact. -0.1. What is the difference between the Rating (1=low 6=high) in Sub-Saharan Africa (developing only) in 2010 and the Rating (1=low 6=high) in Upper middle income in 2012?
Your answer should be very brief. 0.28. What is the difference between the Rating (1=low 6=high) of Sub-Saharan Africa (developing only) in 2010 and the Rating (1=low 6=high) of Cameroon in 2012?
Your response must be concise. -0.45. What is the difference between the Rating (1=low 6=high) of Sub-Saharan Africa (developing only) in 2010 and the Rating (1=low 6=high) of Gambia, The in 2012?
Offer a very short reply. 0.05. What is the difference between the Rating (1=low 6=high) of Upper middle income in 2010 and the Rating (1=low 6=high) of Cameroon in 2012?
Your answer should be very brief. -0.43. What is the difference between the Rating (1=low 6=high) in Upper middle income in 2010 and the Rating (1=low 6=high) in Gambia, The in 2012?
Your response must be concise. 0.07. What is the difference between the Rating (1=low 6=high) in Cameroon in 2010 and the Rating (1=low 6=high) in Gambia, The in 2012?
Provide a short and direct response. 0.17. What is the difference between the Rating (1=low 6=high) of Sub-Saharan Africa (developing only) in 2011 and the Rating (1=low 6=high) of Upper middle income in 2012?
Keep it short and to the point. 0.3. What is the difference between the Rating (1=low 6=high) in Sub-Saharan Africa (developing only) in 2011 and the Rating (1=low 6=high) in Cameroon in 2012?
Offer a very short reply. -0.43. What is the difference between the Rating (1=low 6=high) of Sub-Saharan Africa (developing only) in 2011 and the Rating (1=low 6=high) of Gambia, The in 2012?
Keep it short and to the point. 0.07. What is the difference between the Rating (1=low 6=high) of Upper middle income in 2011 and the Rating (1=low 6=high) of Cameroon in 2012?
Your answer should be compact. -0.58. What is the difference between the Rating (1=low 6=high) in Upper middle income in 2011 and the Rating (1=low 6=high) in Gambia, The in 2012?
Give a very brief answer. -0.08. What is the difference between the Rating (1=low 6=high) in Cameroon in 2011 and the Rating (1=low 6=high) in Gambia, The in 2012?
Ensure brevity in your answer.  0.33. What is the average Rating (1=low 6=high) of Sub-Saharan Africa (developing only) per year?
Provide a succinct answer. 3.36. What is the average Rating (1=low 6=high) in Upper middle income per year?
Your answer should be compact. 3.41. What is the average Rating (1=low 6=high) in Cameroon per year?
Ensure brevity in your answer.  3.61. In the year 2005, what is the difference between the Rating (1=low 6=high) of Sub-Saharan Africa (developing only) and Rating (1=low 6=high) of Upper middle income?
Your answer should be compact. -0.36. In the year 2005, what is the difference between the Rating (1=low 6=high) in Sub-Saharan Africa (developing only) and Rating (1=low 6=high) in Cameroon?
Keep it short and to the point. -0.05. In the year 2005, what is the difference between the Rating (1=low 6=high) of Sub-Saharan Africa (developing only) and Rating (1=low 6=high) of Gambia, The?
Ensure brevity in your answer.  0.28. In the year 2005, what is the difference between the Rating (1=low 6=high) of Upper middle income and Rating (1=low 6=high) of Cameroon?
Your answer should be compact. 0.31. In the year 2005, what is the difference between the Rating (1=low 6=high) in Upper middle income and Rating (1=low 6=high) in Gambia, The?
Provide a succinct answer. 0.64. In the year 2006, what is the difference between the Rating (1=low 6=high) of Sub-Saharan Africa (developing only) and Rating (1=low 6=high) of Upper middle income?
Keep it short and to the point. -0.26. In the year 2006, what is the difference between the Rating (1=low 6=high) in Sub-Saharan Africa (developing only) and Rating (1=low 6=high) in Cameroon?
Make the answer very short. -0.21. In the year 2006, what is the difference between the Rating (1=low 6=high) of Sub-Saharan Africa (developing only) and Rating (1=low 6=high) of Gambia, The?
Give a very brief answer. 0.29. In the year 2006, what is the difference between the Rating (1=low 6=high) of Upper middle income and Rating (1=low 6=high) of Cameroon?
Your response must be concise. 0.06. In the year 2006, what is the difference between the Rating (1=low 6=high) of Upper middle income and Rating (1=low 6=high) of Gambia, The?
Ensure brevity in your answer.  0.56. In the year 2007, what is the difference between the Rating (1=low 6=high) in Sub-Saharan Africa (developing only) and Rating (1=low 6=high) in Upper middle income?
Your answer should be compact. -0.14. In the year 2007, what is the difference between the Rating (1=low 6=high) in Sub-Saharan Africa (developing only) and Rating (1=low 6=high) in Cameroon?
Your answer should be very brief. -0.31. In the year 2007, what is the difference between the Rating (1=low 6=high) in Sub-Saharan Africa (developing only) and Rating (1=low 6=high) in Gambia, The?
Give a very brief answer. 0.02. In the year 2008, what is the difference between the Rating (1=low 6=high) in Sub-Saharan Africa (developing only) and Rating (1=low 6=high) in Upper middle income?
Your answer should be very brief. -0.02. In the year 2008, what is the difference between the Rating (1=low 6=high) of Sub-Saharan Africa (developing only) and Rating (1=low 6=high) of Cameroon?
Ensure brevity in your answer.  -0.34. In the year 2008, what is the difference between the Rating (1=low 6=high) of Sub-Saharan Africa (developing only) and Rating (1=low 6=high) of Gambia, The?
Your answer should be very brief. -0.14. In the year 2008, what is the difference between the Rating (1=low 6=high) in Upper middle income and Rating (1=low 6=high) in Cameroon?
Make the answer very short. -0.32. In the year 2008, what is the difference between the Rating (1=low 6=high) of Upper middle income and Rating (1=low 6=high) of Gambia, The?
Keep it short and to the point. -0.12. In the year 2009, what is the difference between the Rating (1=low 6=high) in Sub-Saharan Africa (developing only) and Rating (1=low 6=high) in Upper middle income?
Your response must be concise. -0.03. In the year 2009, what is the difference between the Rating (1=low 6=high) of Sub-Saharan Africa (developing only) and Rating (1=low 6=high) of Cameroon?
Offer a terse response. -0.28. In the year 2009, what is the difference between the Rating (1=low 6=high) of Sub-Saharan Africa (developing only) and Rating (1=low 6=high) of Gambia, The?
Your answer should be very brief. -0.11. In the year 2009, what is the difference between the Rating (1=low 6=high) of Upper middle income and Rating (1=low 6=high) of Cameroon?
Your answer should be very brief. -0.25. In the year 2009, what is the difference between the Rating (1=low 6=high) in Upper middle income and Rating (1=low 6=high) in Gambia, The?
Ensure brevity in your answer.  -0.08. In the year 2010, what is the difference between the Rating (1=low 6=high) in Sub-Saharan Africa (developing only) and Rating (1=low 6=high) in Upper middle income?
Offer a terse response. -0.02. In the year 2010, what is the difference between the Rating (1=low 6=high) in Sub-Saharan Africa (developing only) and Rating (1=low 6=high) in Cameroon?
Give a very brief answer. -0.12. In the year 2010, what is the difference between the Rating (1=low 6=high) of Sub-Saharan Africa (developing only) and Rating (1=low 6=high) of Gambia, The?
Offer a very short reply. -0.12. In the year 2010, what is the difference between the Rating (1=low 6=high) in Upper middle income and Rating (1=low 6=high) in Gambia, The?
Give a very brief answer. -0.1. In the year 2010, what is the difference between the Rating (1=low 6=high) in Cameroon and Rating (1=low 6=high) in Gambia, The?
Make the answer very short. 0. In the year 2011, what is the difference between the Rating (1=low 6=high) in Sub-Saharan Africa (developing only) and Rating (1=low 6=high) in Upper middle income?
Give a very brief answer. 0.15. In the year 2011, what is the difference between the Rating (1=low 6=high) in Sub-Saharan Africa (developing only) and Rating (1=low 6=high) in Cameroon?
Provide a short and direct response. -0.26. In the year 2011, what is the difference between the Rating (1=low 6=high) of Sub-Saharan Africa (developing only) and Rating (1=low 6=high) of Gambia, The?
Provide a short and direct response. -0.1. In the year 2011, what is the difference between the Rating (1=low 6=high) of Upper middle income and Rating (1=low 6=high) of Cameroon?
Offer a terse response. -0.42. In the year 2011, what is the difference between the Rating (1=low 6=high) in Upper middle income and Rating (1=low 6=high) in Gambia, The?
Offer a very short reply. -0.25. In the year 2012, what is the difference between the Rating (1=low 6=high) of Sub-Saharan Africa (developing only) and Rating (1=low 6=high) of Upper middle income?
Provide a short and direct response. 0.27. In the year 2012, what is the difference between the Rating (1=low 6=high) of Sub-Saharan Africa (developing only) and Rating (1=low 6=high) of Cameroon?
Keep it short and to the point. -0.45. In the year 2012, what is the difference between the Rating (1=low 6=high) of Sub-Saharan Africa (developing only) and Rating (1=low 6=high) of Gambia, The?
Offer a very short reply. 0.05. In the year 2012, what is the difference between the Rating (1=low 6=high) of Upper middle income and Rating (1=low 6=high) of Cameroon?
Provide a succinct answer. -0.73. In the year 2012, what is the difference between the Rating (1=low 6=high) in Upper middle income and Rating (1=low 6=high) in Gambia, The?
Make the answer very short. -0.23. What is the ratio of the Rating (1=low 6=high) of Sub-Saharan Africa (developing only) in 2005 to that in 2006?
Provide a succinct answer. 1. What is the ratio of the Rating (1=low 6=high) of Upper middle income in 2005 to that in 2006?
Provide a succinct answer. 1.02. What is the ratio of the Rating (1=low 6=high) of Cameroon in 2005 to that in 2006?
Make the answer very short. 0.95. What is the ratio of the Rating (1=low 6=high) of Sub-Saharan Africa (developing only) in 2005 to that in 2007?
Provide a succinct answer. 0.98. What is the ratio of the Rating (1=low 6=high) of Upper middle income in 2005 to that in 2007?
Give a very brief answer. 1.04. What is the ratio of the Rating (1=low 6=high) of Gambia, The in 2005 to that in 2007?
Your answer should be very brief. 0.9. What is the ratio of the Rating (1=low 6=high) of Sub-Saharan Africa (developing only) in 2005 to that in 2008?
Offer a very short reply. 0.98. What is the ratio of the Rating (1=low 6=high) of Upper middle income in 2005 to that in 2008?
Keep it short and to the point. 1.08. What is the ratio of the Rating (1=low 6=high) of Cameroon in 2005 to that in 2008?
Make the answer very short. 0.9. What is the ratio of the Rating (1=low 6=high) of Gambia, The in 2005 to that in 2008?
Your response must be concise. 0.86. What is the ratio of the Rating (1=low 6=high) of Sub-Saharan Africa (developing only) in 2005 to that in 2009?
Ensure brevity in your answer.  0.97. What is the ratio of the Rating (1=low 6=high) in Upper middle income in 2005 to that in 2009?
Make the answer very short. 1.06. What is the ratio of the Rating (1=low 6=high) of Cameroon in 2005 to that in 2009?
Offer a terse response. 0.91. What is the ratio of the Rating (1=low 6=high) of Gambia, The in 2005 to that in 2009?
Provide a short and direct response. 0.86. What is the ratio of the Rating (1=low 6=high) of Sub-Saharan Africa (developing only) in 2005 to that in 2010?
Give a very brief answer. 0.97. What is the ratio of the Rating (1=low 6=high) in Upper middle income in 2005 to that in 2010?
Provide a short and direct response. 1.07. What is the ratio of the Rating (1=low 6=high) in Cameroon in 2005 to that in 2010?
Your response must be concise. 0.95. What is the ratio of the Rating (1=low 6=high) in Sub-Saharan Africa (developing only) in 2005 to that in 2011?
Offer a very short reply. 0.96. What is the ratio of the Rating (1=low 6=high) in Upper middle income in 2005 to that in 2011?
Offer a very short reply. 1.12. What is the ratio of the Rating (1=low 6=high) of Cameroon in 2005 to that in 2011?
Provide a succinct answer. 0.91. What is the ratio of the Rating (1=low 6=high) in Sub-Saharan Africa (developing only) in 2005 to that in 2012?
Offer a terse response. 0.97. What is the ratio of the Rating (1=low 6=high) of Upper middle income in 2005 to that in 2012?
Your response must be concise. 1.17. What is the ratio of the Rating (1=low 6=high) of Cameroon in 2005 to that in 2012?
Keep it short and to the point. 0.87. What is the ratio of the Rating (1=low 6=high) in Sub-Saharan Africa (developing only) in 2006 to that in 2007?
Offer a very short reply. 0.98. What is the ratio of the Rating (1=low 6=high) of Upper middle income in 2006 to that in 2007?
Make the answer very short. 1.02. What is the ratio of the Rating (1=low 6=high) of Cameroon in 2006 to that in 2007?
Offer a very short reply. 0.95. What is the ratio of the Rating (1=low 6=high) in Gambia, The in 2006 to that in 2007?
Give a very brief answer. 0.9. What is the ratio of the Rating (1=low 6=high) in Sub-Saharan Africa (developing only) in 2006 to that in 2008?
Provide a short and direct response. 0.98. What is the ratio of the Rating (1=low 6=high) of Upper middle income in 2006 to that in 2008?
Provide a succinct answer. 1.05. What is the ratio of the Rating (1=low 6=high) of Cameroon in 2006 to that in 2008?
Your answer should be very brief. 0.95. What is the ratio of the Rating (1=low 6=high) of Gambia, The in 2006 to that in 2008?
Offer a terse response. 0.86. What is the ratio of the Rating (1=low 6=high) in Upper middle income in 2006 to that in 2009?
Provide a succinct answer. 1.04. What is the ratio of the Rating (1=low 6=high) of Cameroon in 2006 to that in 2009?
Give a very brief answer. 0.95. What is the ratio of the Rating (1=low 6=high) in Gambia, The in 2006 to that in 2009?
Offer a very short reply. 0.86. What is the ratio of the Rating (1=low 6=high) of Sub-Saharan Africa (developing only) in 2006 to that in 2010?
Offer a terse response. 0.97. What is the ratio of the Rating (1=low 6=high) in Upper middle income in 2006 to that in 2010?
Make the answer very short. 1.05. What is the ratio of the Rating (1=low 6=high) of Cameroon in 2006 to that in 2010?
Provide a succinct answer. 1. What is the ratio of the Rating (1=low 6=high) of Gambia, The in 2006 to that in 2010?
Your answer should be very brief. 0.86. What is the ratio of the Rating (1=low 6=high) of Sub-Saharan Africa (developing only) in 2006 to that in 2011?
Give a very brief answer. 0.97. What is the ratio of the Rating (1=low 6=high) in Upper middle income in 2006 to that in 2011?
Ensure brevity in your answer.  1.09. What is the ratio of the Rating (1=low 6=high) in Cameroon in 2006 to that in 2011?
Your response must be concise. 0.95. What is the ratio of the Rating (1=low 6=high) in Gambia, The in 2006 to that in 2011?
Your response must be concise. 0.86. What is the ratio of the Rating (1=low 6=high) of Sub-Saharan Africa (developing only) in 2006 to that in 2012?
Offer a terse response. 0.97. What is the ratio of the Rating (1=low 6=high) of Upper middle income in 2006 to that in 2012?
Offer a terse response. 1.15. What is the ratio of the Rating (1=low 6=high) of Upper middle income in 2007 to that in 2008?
Your answer should be very brief. 1.04. What is the ratio of the Rating (1=low 6=high) in Gambia, The in 2007 to that in 2008?
Give a very brief answer. 0.95. What is the ratio of the Rating (1=low 6=high) in Upper middle income in 2007 to that in 2009?
Your answer should be compact. 1.02. What is the ratio of the Rating (1=low 6=high) of Cameroon in 2007 to that in 2009?
Your response must be concise. 1. What is the ratio of the Rating (1=low 6=high) of Gambia, The in 2007 to that in 2009?
Ensure brevity in your answer.  0.95. What is the ratio of the Rating (1=low 6=high) of Upper middle income in 2007 to that in 2010?
Provide a succinct answer. 1.03. What is the ratio of the Rating (1=low 6=high) in Cameroon in 2007 to that in 2010?
Offer a very short reply. 1.05. What is the ratio of the Rating (1=low 6=high) of Upper middle income in 2007 to that in 2011?
Ensure brevity in your answer.  1.08. What is the ratio of the Rating (1=low 6=high) in Cameroon in 2007 to that in 2011?
Give a very brief answer. 1. What is the ratio of the Rating (1=low 6=high) of Upper middle income in 2007 to that in 2012?
Offer a very short reply. 1.13. What is the ratio of the Rating (1=low 6=high) in Cameroon in 2007 to that in 2012?
Make the answer very short. 0.96. What is the ratio of the Rating (1=low 6=high) in Sub-Saharan Africa (developing only) in 2008 to that in 2009?
Make the answer very short. 0.99. What is the ratio of the Rating (1=low 6=high) of Upper middle income in 2008 to that in 2009?
Offer a very short reply. 0.99. What is the ratio of the Rating (1=low 6=high) in Cameroon in 2008 to that in 2009?
Offer a terse response. 1.01. What is the ratio of the Rating (1=low 6=high) in Sub-Saharan Africa (developing only) in 2008 to that in 2010?
Your response must be concise. 1. What is the ratio of the Rating (1=low 6=high) in Cameroon in 2008 to that in 2010?
Keep it short and to the point. 1.06. What is the ratio of the Rating (1=low 6=high) in Upper middle income in 2008 to that in 2011?
Make the answer very short. 1.04. What is the ratio of the Rating (1=low 6=high) in Cameroon in 2008 to that in 2011?
Offer a terse response. 1.01. What is the ratio of the Rating (1=low 6=high) of Gambia, The in 2008 to that in 2011?
Offer a very short reply. 1. What is the ratio of the Rating (1=low 6=high) of Sub-Saharan Africa (developing only) in 2008 to that in 2012?
Keep it short and to the point. 1. What is the ratio of the Rating (1=low 6=high) of Upper middle income in 2008 to that in 2012?
Your answer should be very brief. 1.09. What is the ratio of the Rating (1=low 6=high) of Cameroon in 2008 to that in 2012?
Give a very brief answer. 0.97. What is the ratio of the Rating (1=low 6=high) of Gambia, The in 2008 to that in 2012?
Your answer should be compact. 1.05. What is the ratio of the Rating (1=low 6=high) of Sub-Saharan Africa (developing only) in 2009 to that in 2010?
Give a very brief answer. 1. What is the ratio of the Rating (1=low 6=high) of Cameroon in 2009 to that in 2010?
Your response must be concise. 1.05. What is the ratio of the Rating (1=low 6=high) of Gambia, The in 2009 to that in 2010?
Your answer should be very brief. 1. What is the ratio of the Rating (1=low 6=high) in Upper middle income in 2009 to that in 2011?
Keep it short and to the point. 1.05. What is the ratio of the Rating (1=low 6=high) in Cameroon in 2009 to that in 2011?
Offer a very short reply. 1. What is the ratio of the Rating (1=low 6=high) in Gambia, The in 2009 to that in 2011?
Keep it short and to the point. 1. What is the ratio of the Rating (1=low 6=high) in Sub-Saharan Africa (developing only) in 2009 to that in 2012?
Provide a short and direct response. 1. What is the ratio of the Rating (1=low 6=high) in Cameroon in 2009 to that in 2012?
Provide a succinct answer. 0.96. What is the ratio of the Rating (1=low 6=high) of Upper middle income in 2010 to that in 2011?
Provide a succinct answer. 1.05. What is the ratio of the Rating (1=low 6=high) in Cameroon in 2010 to that in 2011?
Give a very brief answer. 0.95. What is the ratio of the Rating (1=low 6=high) in Gambia, The in 2010 to that in 2011?
Provide a short and direct response. 1. What is the ratio of the Rating (1=low 6=high) of Upper middle income in 2010 to that in 2012?
Provide a succinct answer. 1.09. What is the ratio of the Rating (1=low 6=high) in Cameroon in 2010 to that in 2012?
Offer a terse response. 0.91. What is the ratio of the Rating (1=low 6=high) in Sub-Saharan Africa (developing only) in 2011 to that in 2012?
Offer a very short reply. 1.01. What is the ratio of the Rating (1=low 6=high) of Upper middle income in 2011 to that in 2012?
Offer a very short reply. 1.05. What is the ratio of the Rating (1=low 6=high) of Cameroon in 2011 to that in 2012?
Your answer should be very brief. 0.96. What is the difference between the highest and the second highest Rating (1=low 6=high) in Sub-Saharan Africa (developing only)?
Provide a succinct answer. 0.02. What is the difference between the highest and the second highest Rating (1=low 6=high) in Upper middle income?
Your answer should be compact. 0.08. What is the difference between the highest and the second highest Rating (1=low 6=high) of Cameroon?
Your answer should be very brief. 0.13. What is the difference between the highest and the second highest Rating (1=low 6=high) of Gambia, The?
Give a very brief answer. 0. What is the difference between the highest and the lowest Rating (1=low 6=high) in Sub-Saharan Africa (developing only)?
Ensure brevity in your answer.  0.12. What is the difference between the highest and the lowest Rating (1=low 6=high) of Upper middle income?
Provide a succinct answer. 0.53. What is the difference between the highest and the lowest Rating (1=low 6=high) of Cameroon?
Keep it short and to the point. 0.5. 